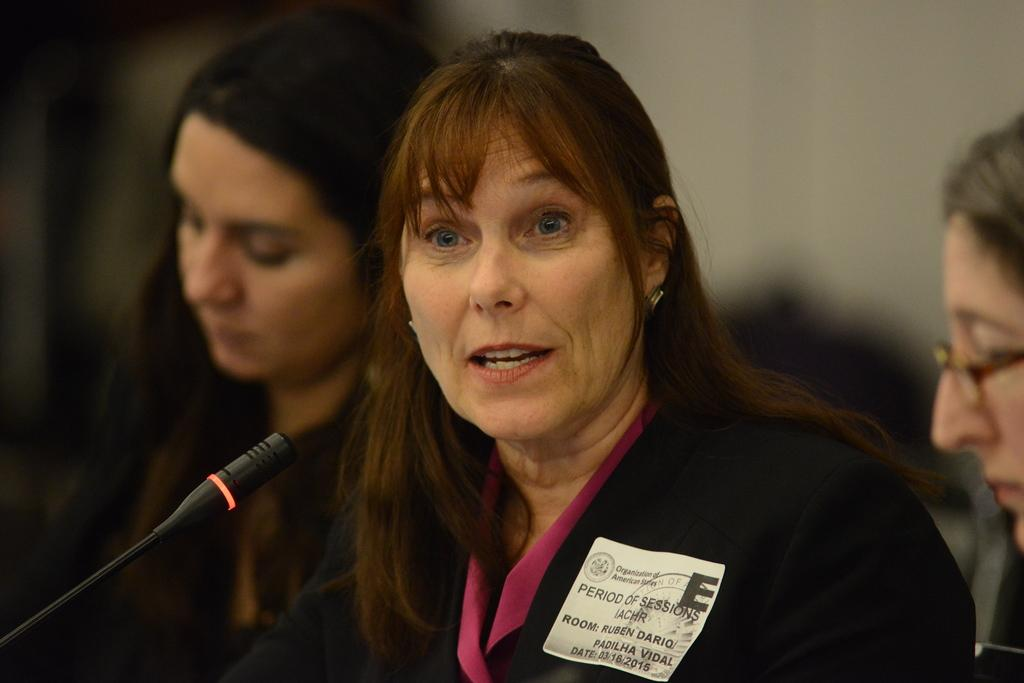Who is the main subject in the image? There is a woman in the middle of the image. What is the woman holding or using in the image? The woman has a microphone in front of her. Can you describe any additional details about the woman in the image? The woman has a badge on her coat. Who else is present in the image? There are two other women on either side of the central woman. What type of slope can be seen in the image? There is no slope present in the image. Can you tell me how many notes the woman is holding in the image? The woman is not holding any notes in the image; she is holding a microphone. 